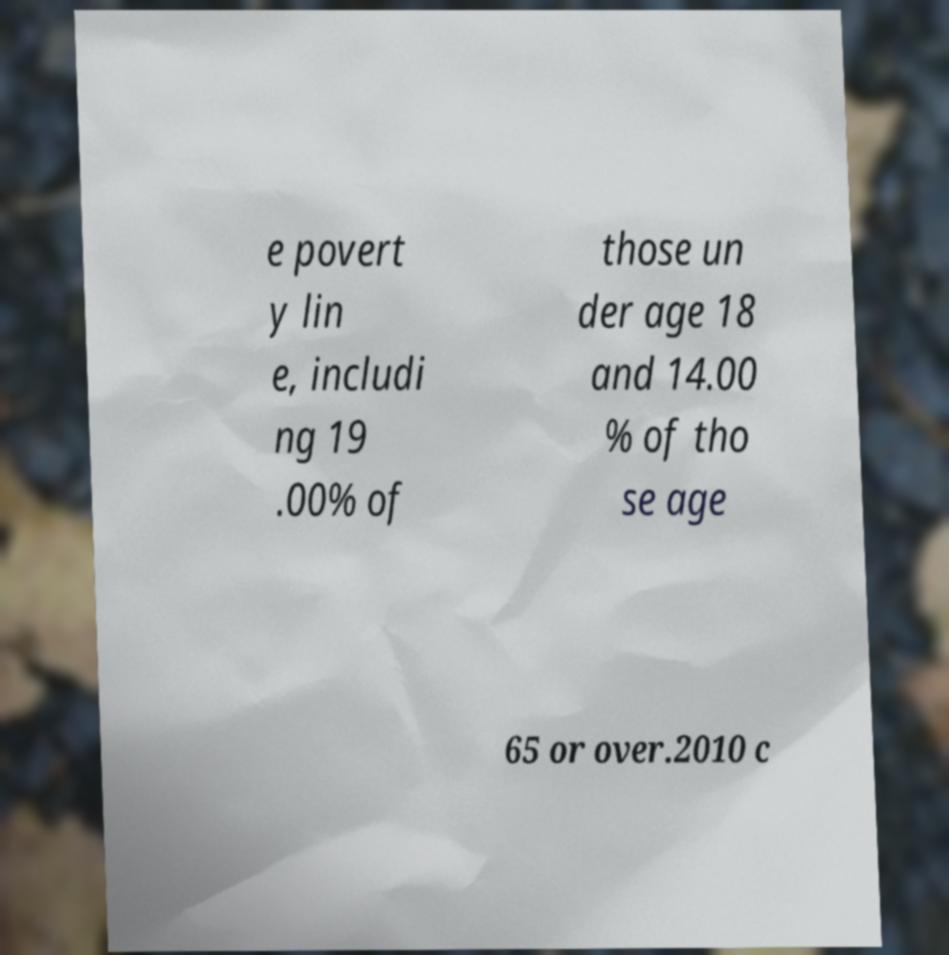Can you read and provide the text displayed in the image?This photo seems to have some interesting text. Can you extract and type it out for me? e povert y lin e, includi ng 19 .00% of those un der age 18 and 14.00 % of tho se age 65 or over.2010 c 